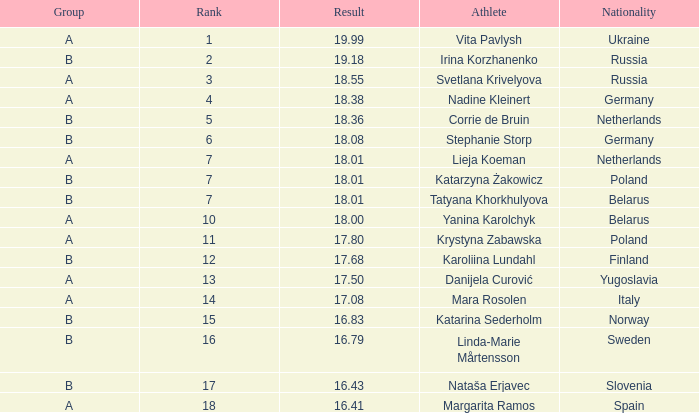Which athlete, has an 18.55 result Svetlana Krivelyova. 